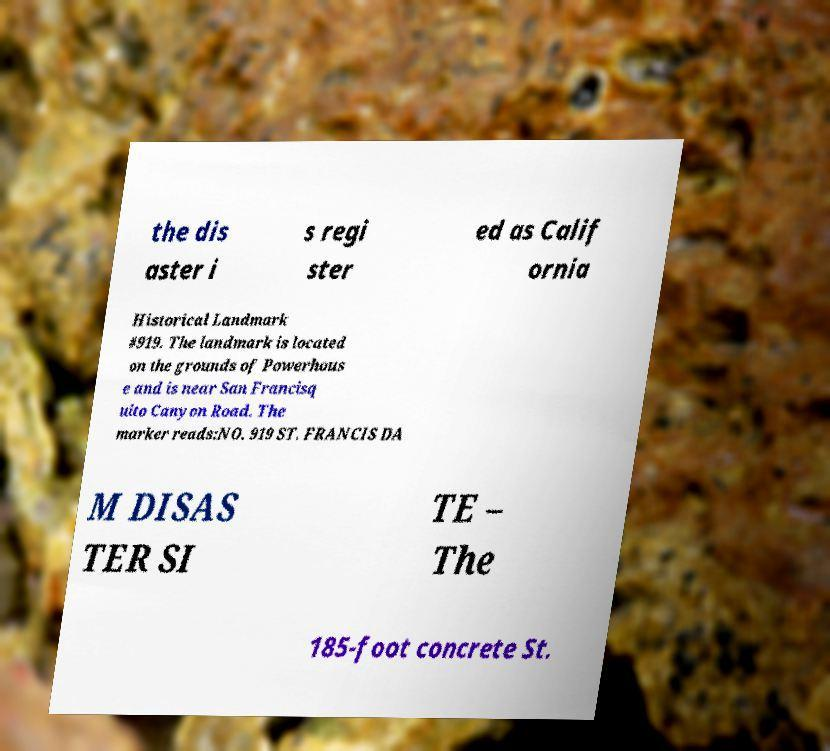What messages or text are displayed in this image? I need them in a readable, typed format. the dis aster i s regi ster ed as Calif ornia Historical Landmark #919. The landmark is located on the grounds of Powerhous e and is near San Francisq uito Canyon Road. The marker reads:NO. 919 ST. FRANCIS DA M DISAS TER SI TE – The 185-foot concrete St. 